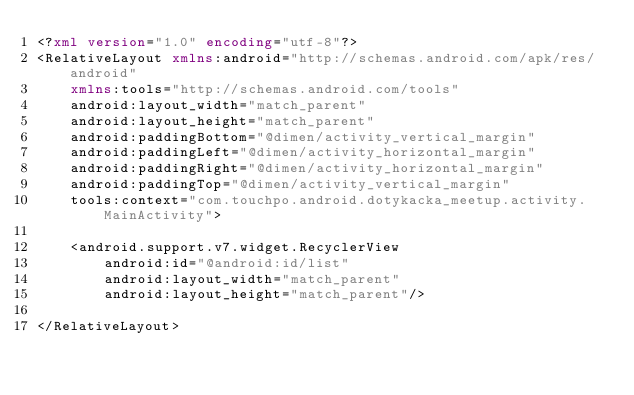Convert code to text. <code><loc_0><loc_0><loc_500><loc_500><_XML_><?xml version="1.0" encoding="utf-8"?>
<RelativeLayout xmlns:android="http://schemas.android.com/apk/res/android"
    xmlns:tools="http://schemas.android.com/tools"
    android:layout_width="match_parent"
    android:layout_height="match_parent"
    android:paddingBottom="@dimen/activity_vertical_margin"
    android:paddingLeft="@dimen/activity_horizontal_margin"
    android:paddingRight="@dimen/activity_horizontal_margin"
    android:paddingTop="@dimen/activity_vertical_margin"
    tools:context="com.touchpo.android.dotykacka_meetup.activity.MainActivity">

    <android.support.v7.widget.RecyclerView
        android:id="@android:id/list"
        android:layout_width="match_parent"
        android:layout_height="match_parent"/>

</RelativeLayout>
</code> 